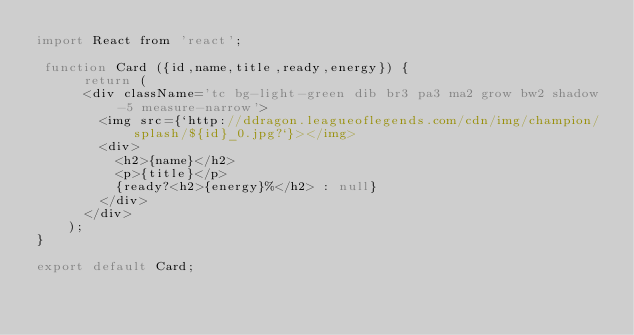Convert code to text. <code><loc_0><loc_0><loc_500><loc_500><_JavaScript_>import React from 'react';

 function Card ({id,name,title,ready,energy}) {
      return (
      <div className='tc bg-light-green dib br3 pa3 ma2 grow bw2 shadow-5 measure-narrow'>
        <img src={`http://ddragon.leagueoflegends.com/cdn/img/champion/splash/${id}_0.jpg?`}></img>
        <div>
          <h2>{name}</h2>
          <p>{title}</p>
          {ready?<h2>{energy}%</h2> : null}
        </div>
      </div>
    );
}

export default Card;
</code> 